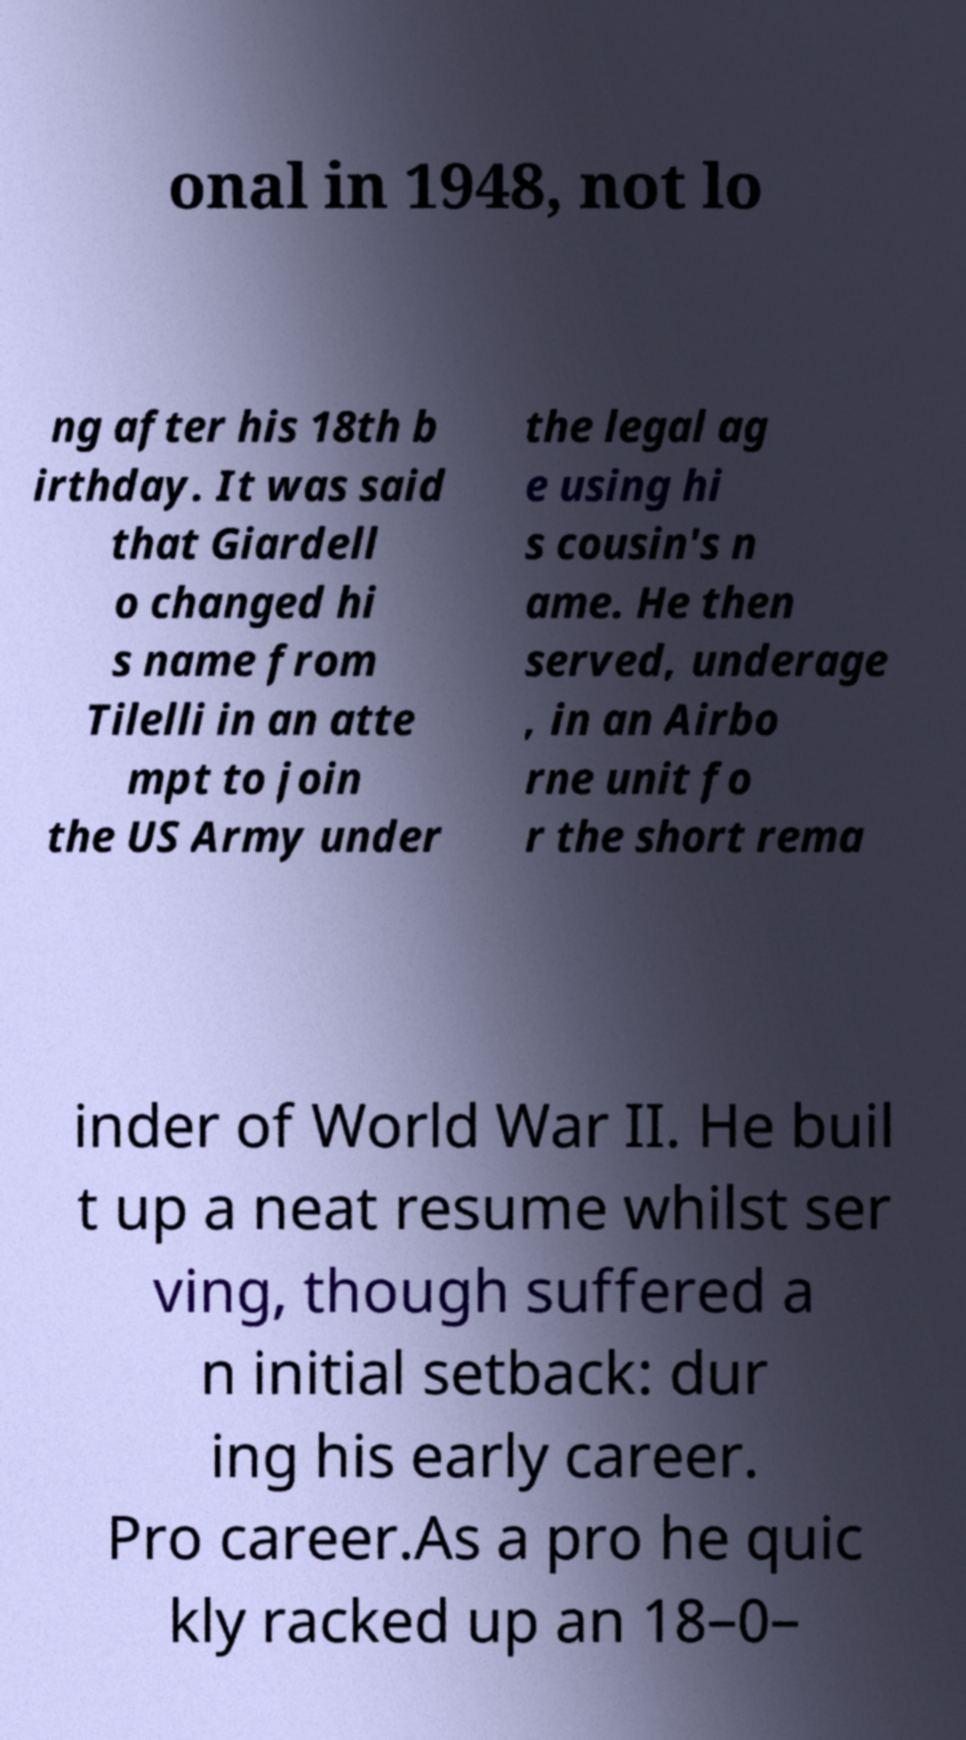What messages or text are displayed in this image? I need them in a readable, typed format. onal in 1948, not lo ng after his 18th b irthday. It was said that Giardell o changed hi s name from Tilelli in an atte mpt to join the US Army under the legal ag e using hi s cousin's n ame. He then served, underage , in an Airbo rne unit fo r the short rema inder of World War II. He buil t up a neat resume whilst ser ving, though suffered a n initial setback: dur ing his early career. Pro career.As a pro he quic kly racked up an 18–0– 